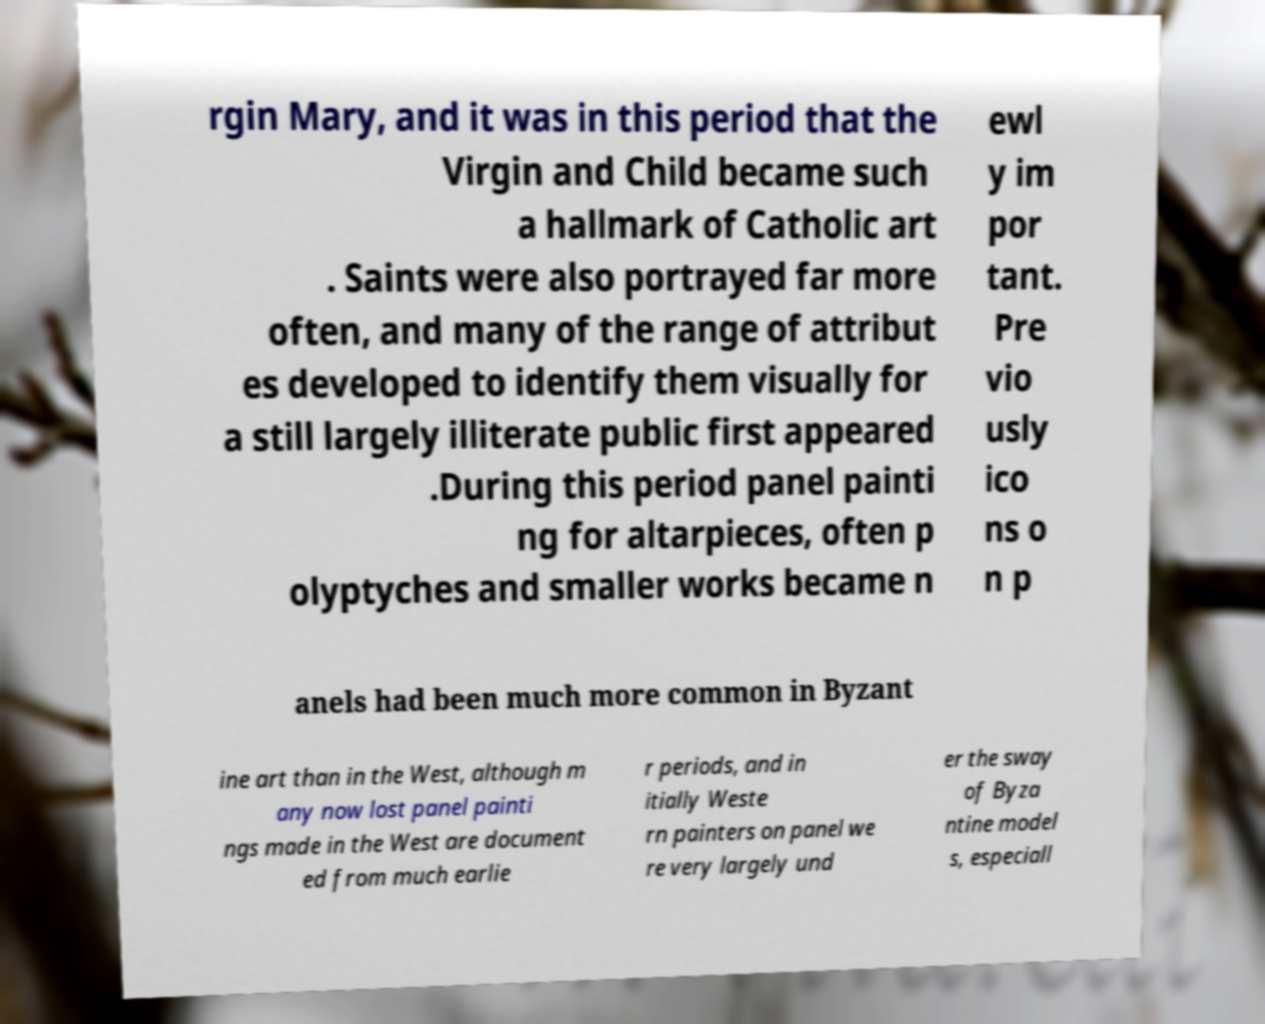Could you extract and type out the text from this image? rgin Mary, and it was in this period that the Virgin and Child became such a hallmark of Catholic art . Saints were also portrayed far more often, and many of the range of attribut es developed to identify them visually for a still largely illiterate public first appeared .During this period panel painti ng for altarpieces, often p olyptyches and smaller works became n ewl y im por tant. Pre vio usly ico ns o n p anels had been much more common in Byzant ine art than in the West, although m any now lost panel painti ngs made in the West are document ed from much earlie r periods, and in itially Weste rn painters on panel we re very largely und er the sway of Byza ntine model s, especiall 